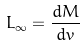<formula> <loc_0><loc_0><loc_500><loc_500>L _ { \infty } = \frac { d M } { d v }</formula> 